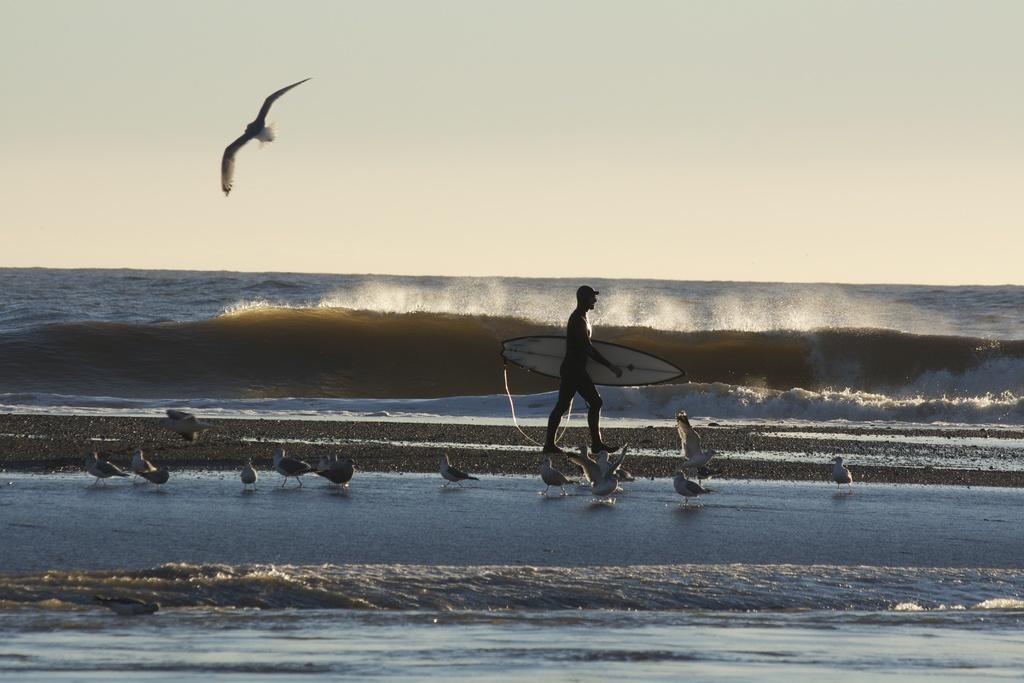What is the man in the image doing? The man is walking in the image. What can be seen in the background of the image? There is water visible in the image. Are there any animals present in the image? Yes, there is at least one bird in the image. What part of the natural environment is visible in the image? The sky is visible in the image. Can you tell me how many apples the robin is holding in the image? There is no robin or apple present in the image. What type of credit card is the man using in the image? There is no credit card or any indication of a financial transaction in the image. 